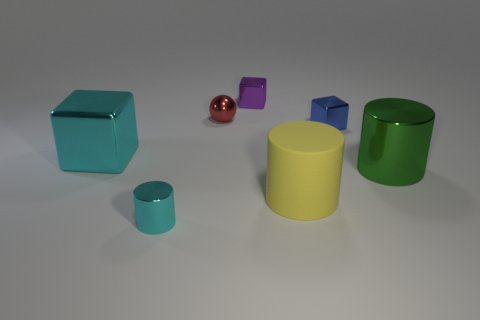Subtract all green spheres. Subtract all yellow cylinders. How many spheres are left? 1 Add 2 large yellow rubber cylinders. How many objects exist? 9 Subtract all spheres. How many objects are left? 6 Add 6 small metal balls. How many small metal balls exist? 7 Subtract 1 blue blocks. How many objects are left? 6 Subtract all tiny blue spheres. Subtract all tiny cyan metallic cylinders. How many objects are left? 6 Add 4 yellow cylinders. How many yellow cylinders are left? 5 